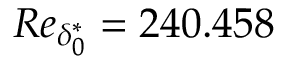<formula> <loc_0><loc_0><loc_500><loc_500>R e _ { \delta _ { 0 } ^ { * } } = 2 4 0 . 4 5 8</formula> 